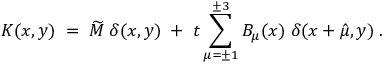Convert formula to latex. <formula><loc_0><loc_0><loc_500><loc_500>K ( x , y ) \, = \, \widetilde { M } \, \delta ( x , y ) \, + \, t \sum _ { \mu = \pm 1 } ^ { \pm 3 } B _ { \mu } ( x ) \, \delta ( x + \hat { \mu } , y ) \, .</formula> 